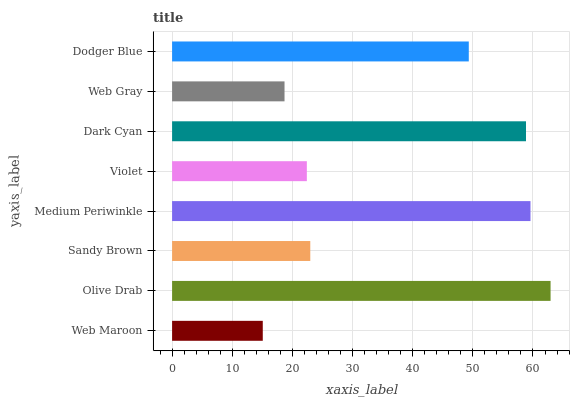Is Web Maroon the minimum?
Answer yes or no. Yes. Is Olive Drab the maximum?
Answer yes or no. Yes. Is Sandy Brown the minimum?
Answer yes or no. No. Is Sandy Brown the maximum?
Answer yes or no. No. Is Olive Drab greater than Sandy Brown?
Answer yes or no. Yes. Is Sandy Brown less than Olive Drab?
Answer yes or no. Yes. Is Sandy Brown greater than Olive Drab?
Answer yes or no. No. Is Olive Drab less than Sandy Brown?
Answer yes or no. No. Is Dodger Blue the high median?
Answer yes or no. Yes. Is Sandy Brown the low median?
Answer yes or no. Yes. Is Web Maroon the high median?
Answer yes or no. No. Is Dark Cyan the low median?
Answer yes or no. No. 